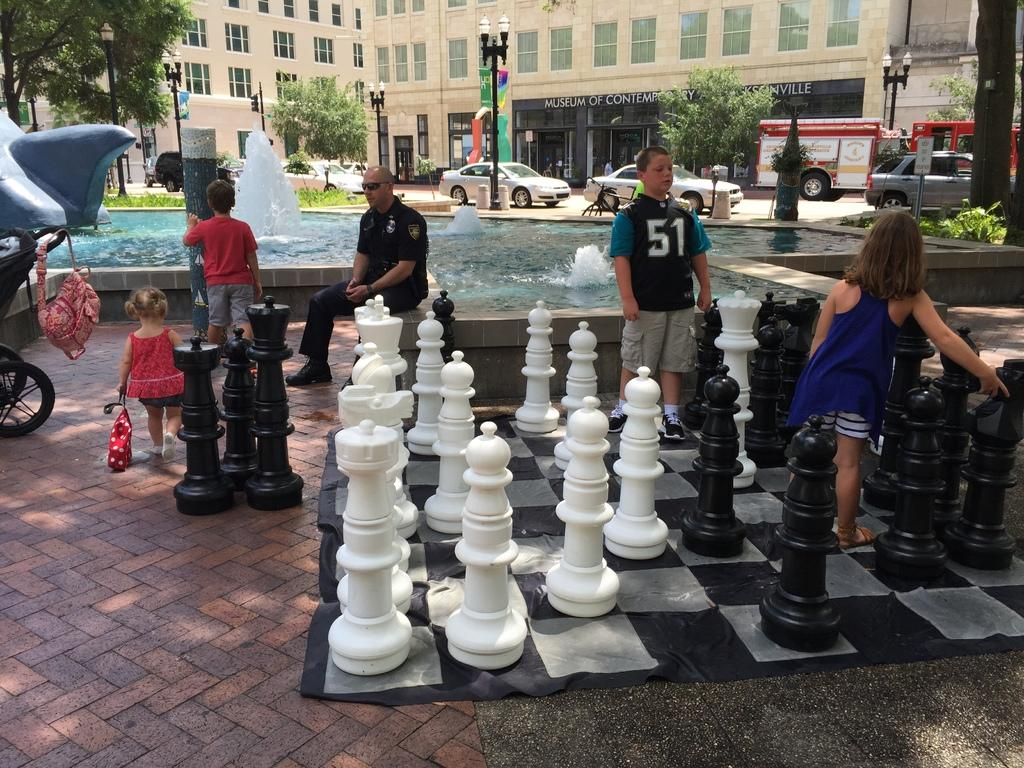How many people are in the image? There are people in the image, but the exact number cannot be determined from the provided facts. What game is being played in the image? There is a chessboard in the image, so it is likely that people are playing chess. What structures are present in the image? There are poles and a building visible in the image. What type of lighting is present in the image? There are lights in the image. What type of natural elements can be seen in the image? There are trees, plants, grass, and water visible in the image. What else can be seen in the image? There are vehicles in the image. What is visible in the background of the image? There is a building in the background of the image. What type of calendar is hanging on the wall in the image? There is no mention of a calendar in the provided facts, so it cannot be determined if there is one present in the image. 